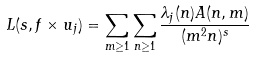Convert formula to latex. <formula><loc_0><loc_0><loc_500><loc_500>L ( s , f \times u _ { j } ) = \sum _ { m \geq 1 } \sum _ { n \geq 1 } \frac { \lambda _ { j } ( n ) A ( n , m ) } { ( m ^ { 2 } n ) ^ { s } }</formula> 